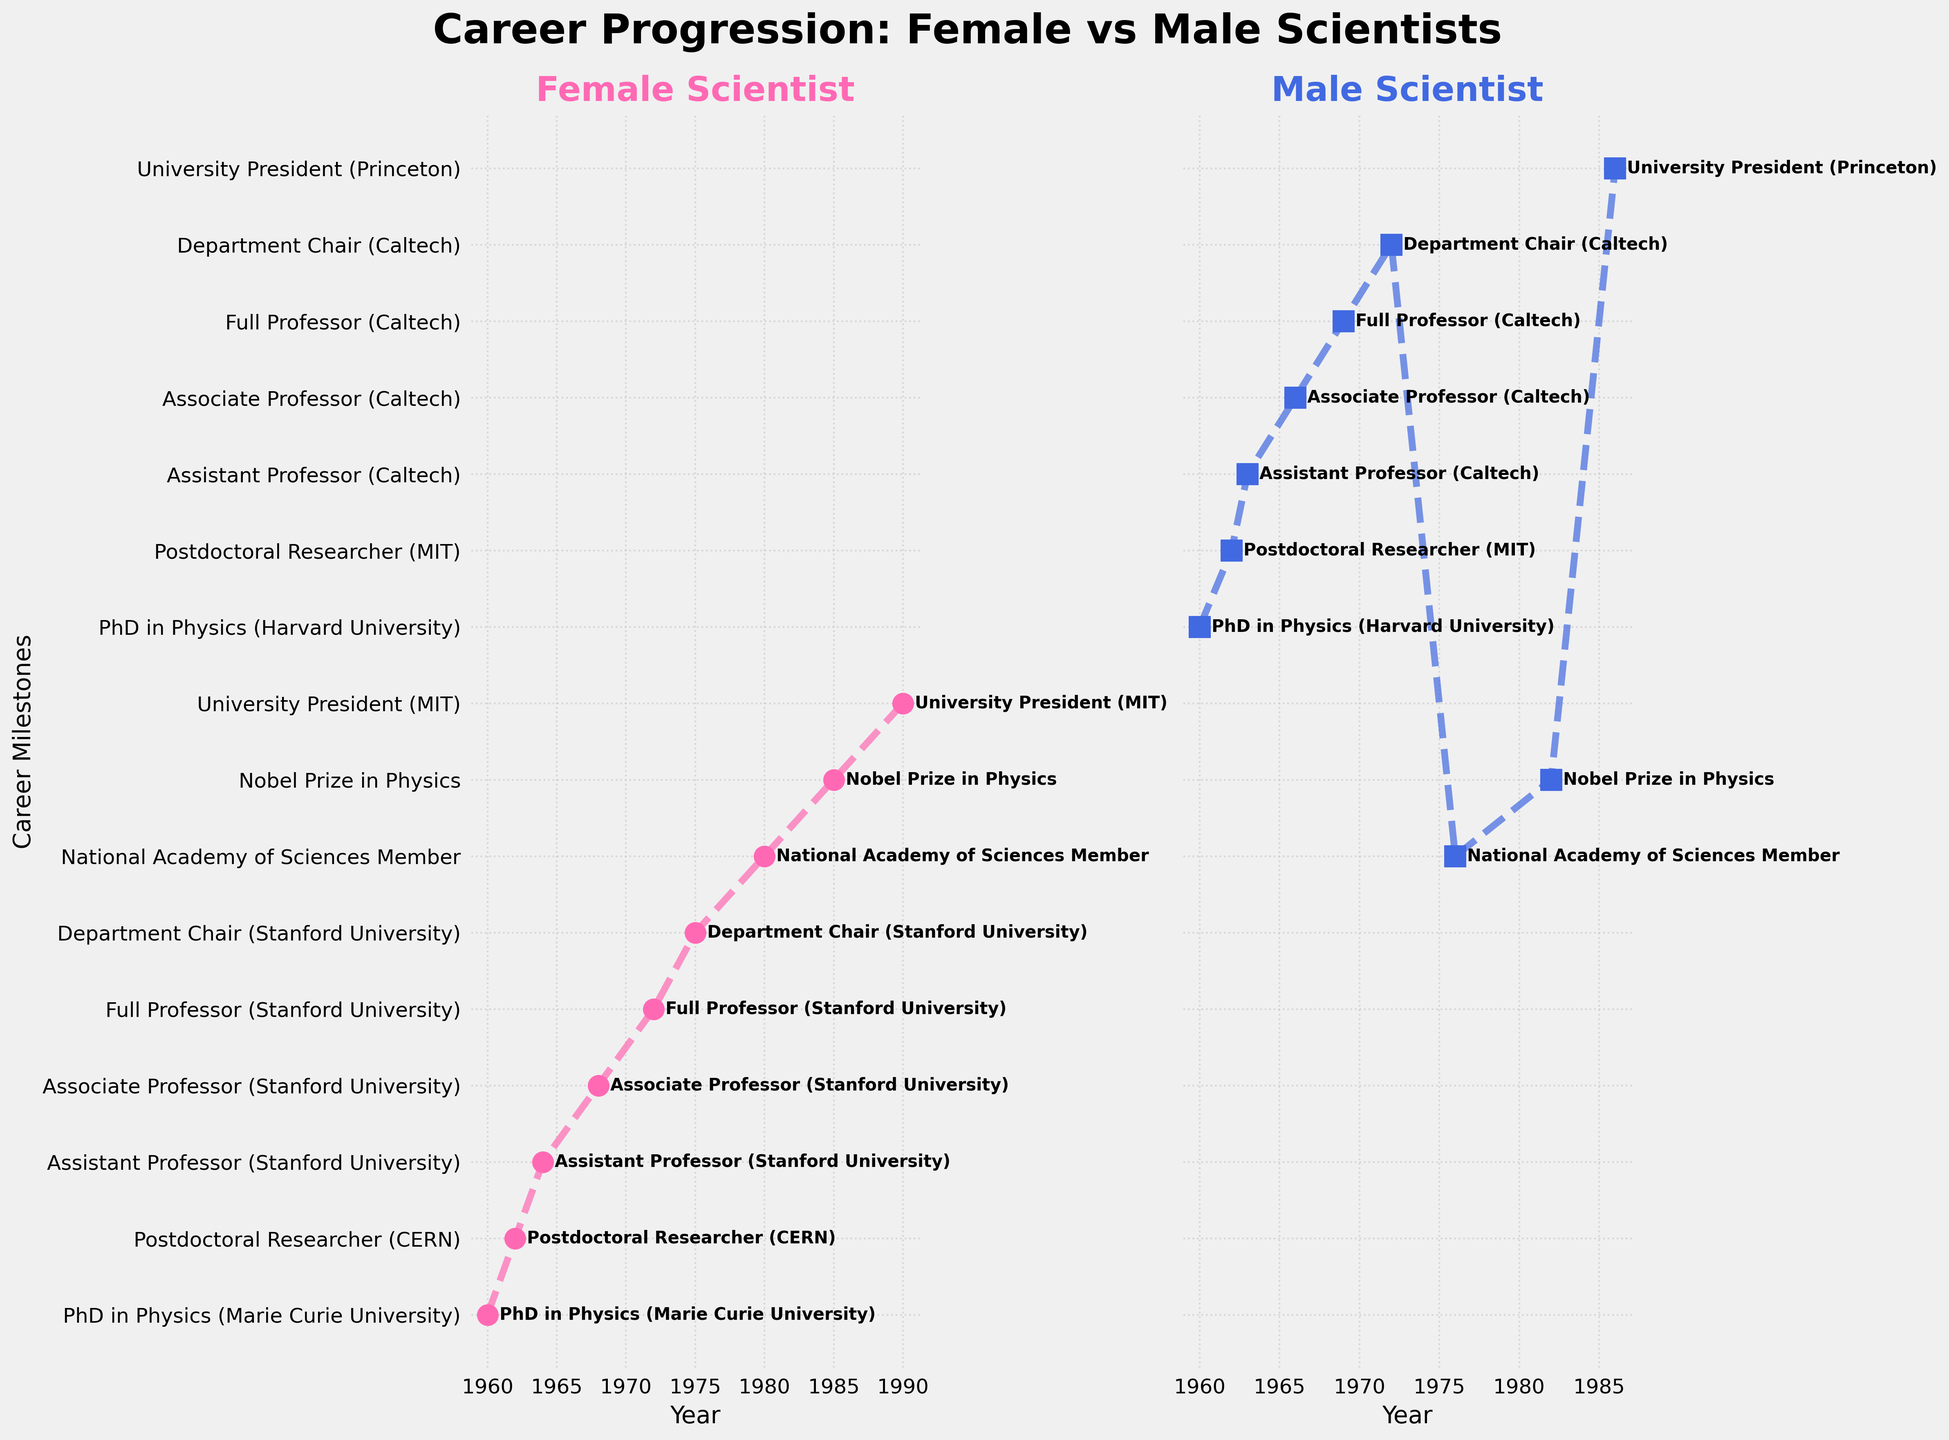What year did the female scientist attain her PhD? The vertical subplot for the female scientist shows the first milestone at the year 1960, under the label "PhD in Physics (Marie Curie University)".
Answer: 1960 What was the first milestone achieved by the male scientist? The earliest milestone on the vertical subplot for the male scientist is in 1960, labeled "PhD in Physics (Harvard University)".
Answer: PhD in Physics (Harvard University) How many years did it take for the female scientist to become a full professor after completing a PhD? The female scientist achieved her PhD in 1960 and became a full professor in 1972. So, 1972 - 1960 = 12 years.
Answer: 12 years Which milestone did both male and female scientists achieve in the same year? By checking the vertical subplots for both scientists, the same year milestone is seen in 1962 for the position "Postdoctoral Researcher".
Answer: Postdoctoral Researcher Who became the university president first, the male or the female scientist? The male scientist became the university president in 1986, whereas the female scientist became the university president in 1990.
Answer: Male scientist Compare the years when the male and female scientists were elected as National Academy of Sciences members. Which one was elected earlier and by how many years? The female scientist was elected in 1980, and the male scientist was elected in 1976. Therefore, the male scientist was elected earlier by 1980 - 1976 = 4 years.
Answer: Male scientist, by 4 years How long did it take for the female scientist to go from assistant professor to department chair? The female scientist became an assistant professor in 1964 and a department chair in 1975. So, 1975 - 1964 = 11 years.
Answer: 11 years Between obtaining a PhD and winning a Nobel Prize, how many years did it take for the male scientist? The male scientist obtained a PhD in 1960 and won the Nobel Prize in 1982. Thus, 1982 - 1960 = 22 years.
Answer: 22 years What is the color used to denote data points for the female scientist? The vertical subplot for the female scientist uses a pink color for the data points.
Answer: Pink Compare the time it took for both the male and female scientists to go from associate professor to full professor. The female scientist became an associate professor in 1968 and a full professor in 1972, taking 4 years. The male scientist became an associate professor in 1966 and a full professor in 1969, taking 3 years. The male scientist took less time by 1 year.
Answer: Male scientist, by 1 year 